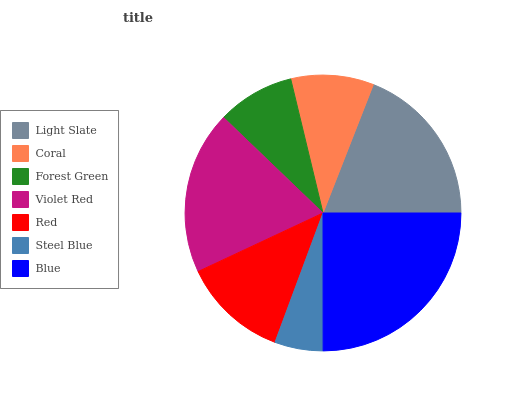Is Steel Blue the minimum?
Answer yes or no. Yes. Is Blue the maximum?
Answer yes or no. Yes. Is Coral the minimum?
Answer yes or no. No. Is Coral the maximum?
Answer yes or no. No. Is Light Slate greater than Coral?
Answer yes or no. Yes. Is Coral less than Light Slate?
Answer yes or no. Yes. Is Coral greater than Light Slate?
Answer yes or no. No. Is Light Slate less than Coral?
Answer yes or no. No. Is Red the high median?
Answer yes or no. Yes. Is Red the low median?
Answer yes or no. Yes. Is Steel Blue the high median?
Answer yes or no. No. Is Blue the low median?
Answer yes or no. No. 